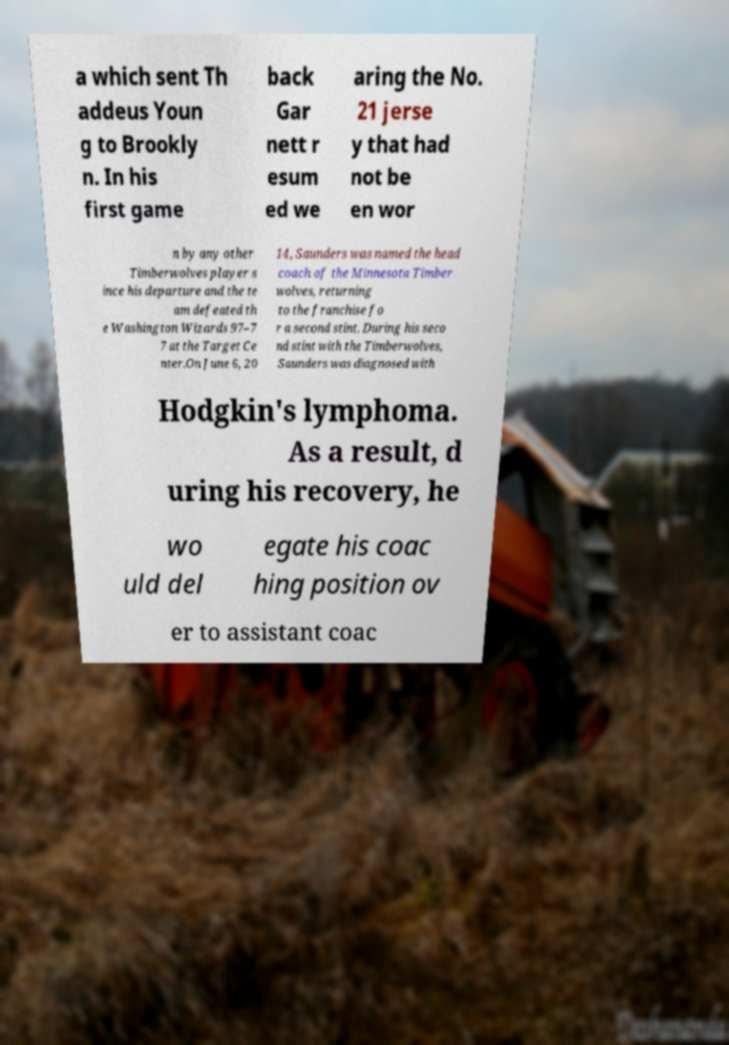Please identify and transcribe the text found in this image. a which sent Th addeus Youn g to Brookly n. In his first game back Gar nett r esum ed we aring the No. 21 jerse y that had not be en wor n by any other Timberwolves player s ince his departure and the te am defeated th e Washington Wizards 97–7 7 at the Target Ce nter.On June 6, 20 14, Saunders was named the head coach of the Minnesota Timber wolves, returning to the franchise fo r a second stint. During his seco nd stint with the Timberwolves, Saunders was diagnosed with Hodgkin's lymphoma. As a result, d uring his recovery, he wo uld del egate his coac hing position ov er to assistant coac 